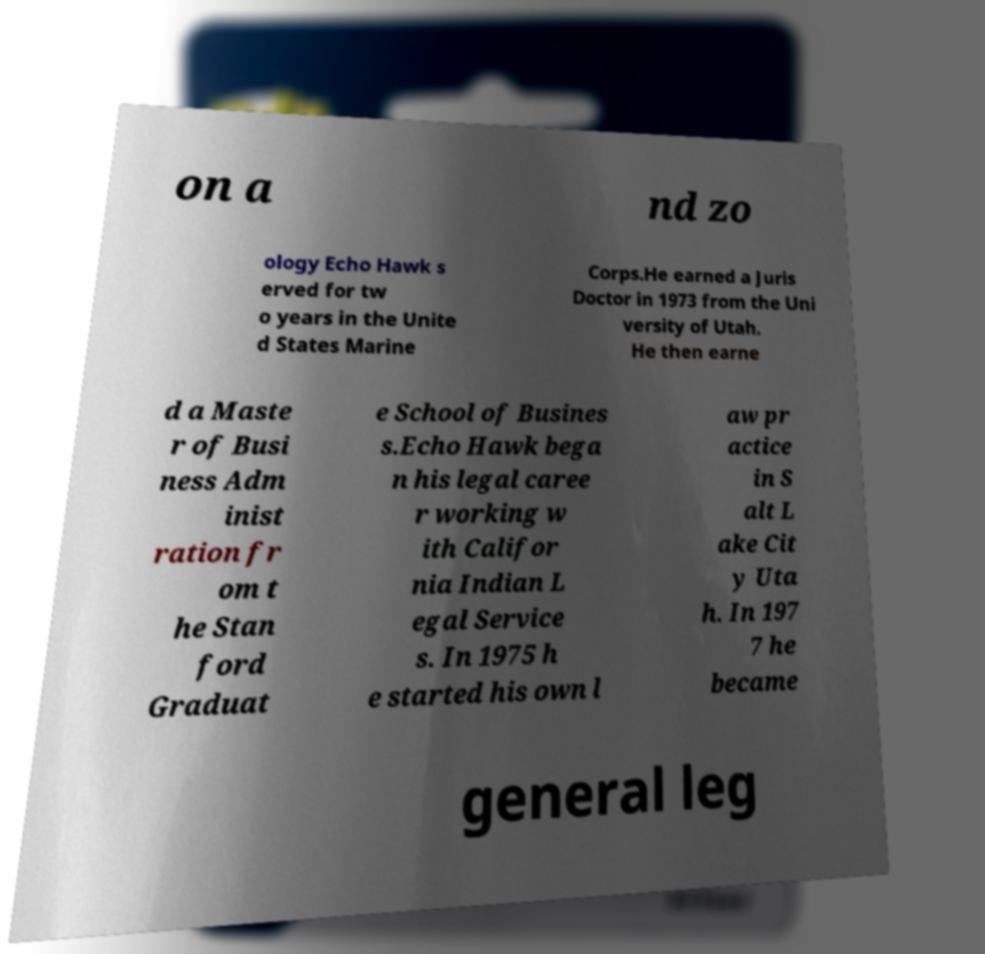Can you read and provide the text displayed in the image?This photo seems to have some interesting text. Can you extract and type it out for me? on a nd zo ology Echo Hawk s erved for tw o years in the Unite d States Marine Corps.He earned a Juris Doctor in 1973 from the Uni versity of Utah. He then earne d a Maste r of Busi ness Adm inist ration fr om t he Stan ford Graduat e School of Busines s.Echo Hawk bega n his legal caree r working w ith Califor nia Indian L egal Service s. In 1975 h e started his own l aw pr actice in S alt L ake Cit y Uta h. In 197 7 he became general leg 